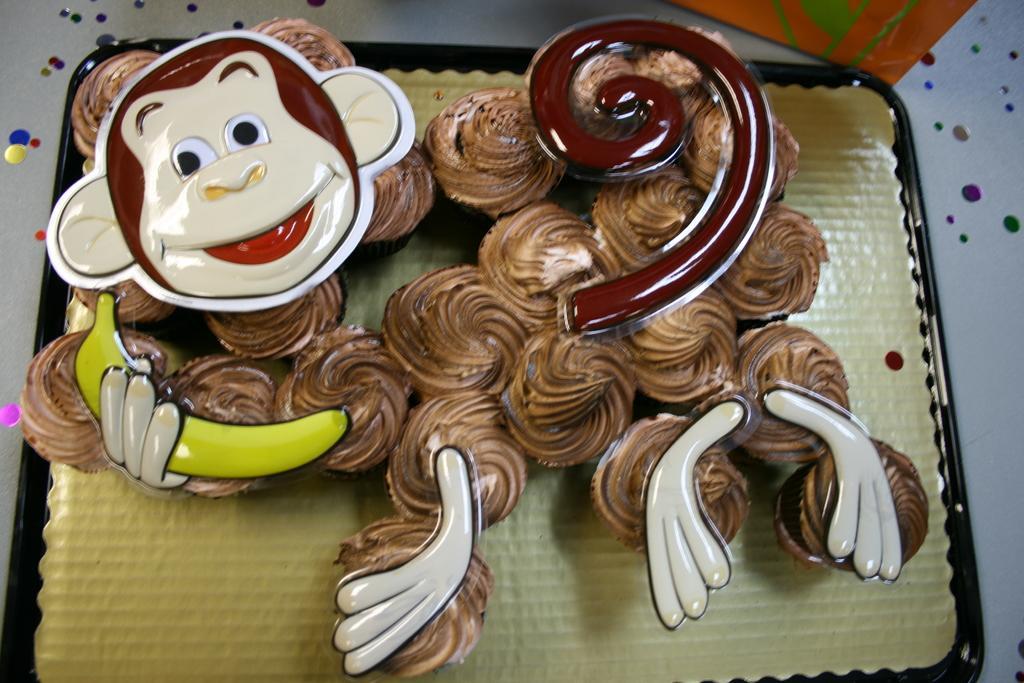How would you summarize this image in a sentence or two? In this image I can see few cupcakes are placed on a tray. At the top there is orange color object. On the cupcakes, I can see the cream and few masks of a monkey. 